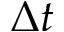Convert formula to latex. <formula><loc_0><loc_0><loc_500><loc_500>\Delta t</formula> 